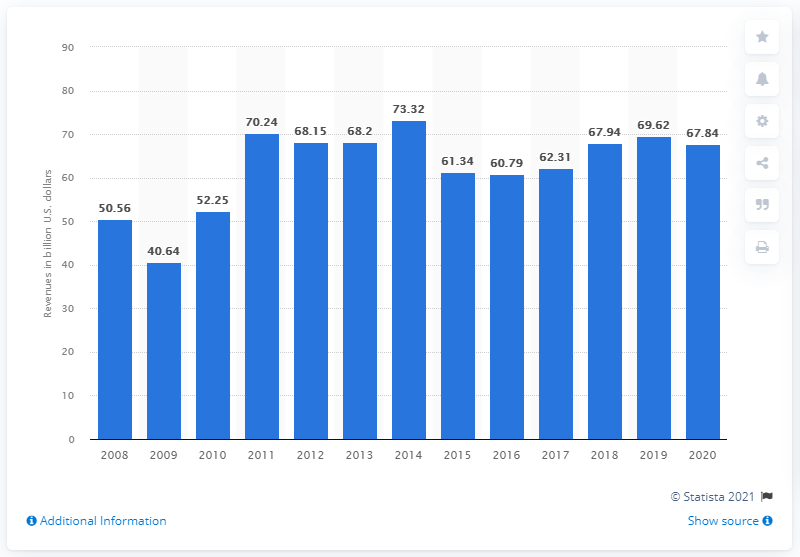Mention a couple of crucial points in this snapshot. In 2020, MetLife's revenues reached a total of 67.84 billion U.S. dollars. MetLife achieved its peak revenue of $73.32 billion in 2014. MetLife's revenue in 2019 was 69.62 billion dollars. MetLife's revenue in 2020 was 67.84. 